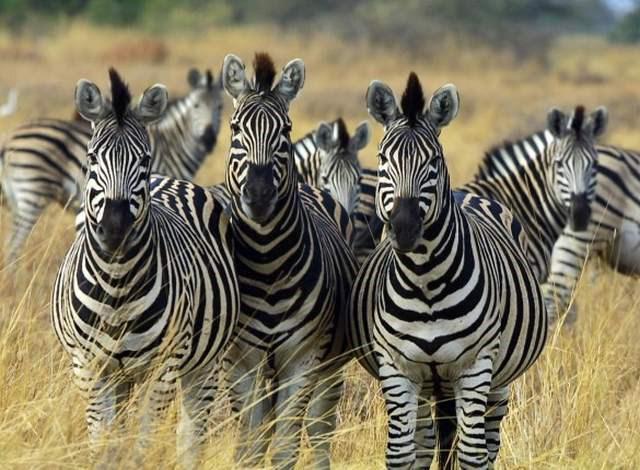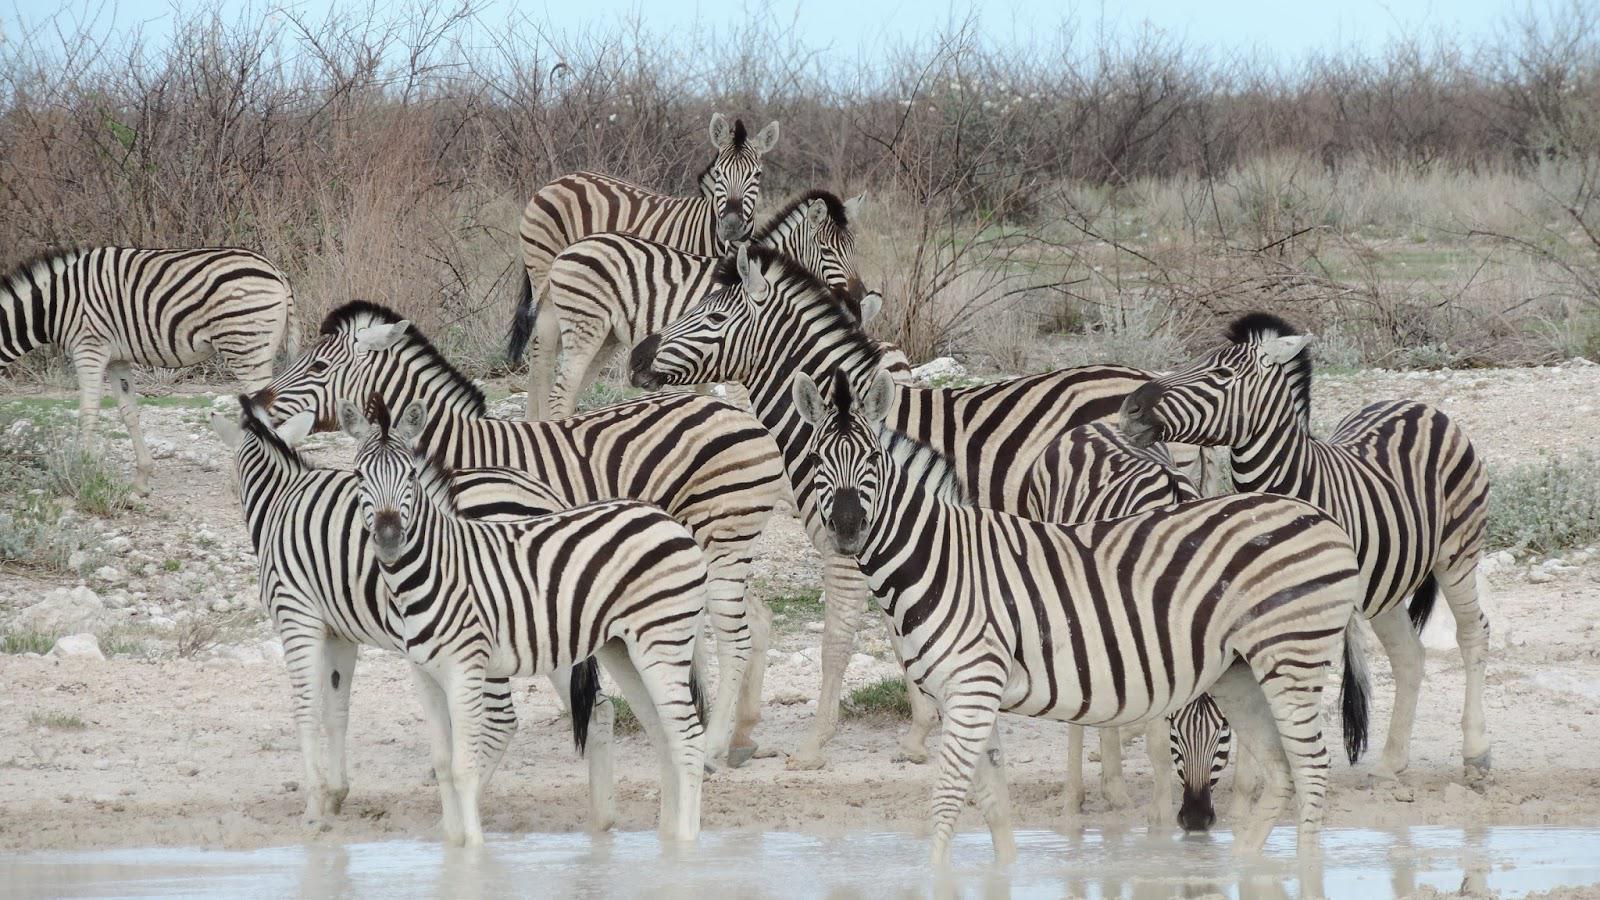The first image is the image on the left, the second image is the image on the right. For the images displayed, is the sentence "The left image shows several forward-turned zebra in the foreground, and the right image includes several zebras standing in water." factually correct? Answer yes or no. Yes. The first image is the image on the left, the second image is the image on the right. For the images displayed, is the sentence "Some zebras are in water." factually correct? Answer yes or no. Yes. 